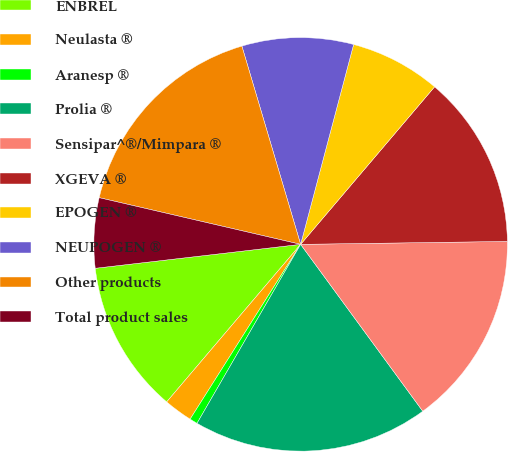Convert chart to OTSL. <chart><loc_0><loc_0><loc_500><loc_500><pie_chart><fcel>ENBREL<fcel>Neulasta ®<fcel>Aranesp ®<fcel>Prolia ®<fcel>Sensipar^®/Mimpara ®<fcel>XGEVA ®<fcel>EPOGEN ®<fcel>NEUPOGEN ®<fcel>Other products<fcel>Total product sales<nl><fcel>11.94%<fcel>2.24%<fcel>0.62%<fcel>18.41%<fcel>15.17%<fcel>13.56%<fcel>7.09%<fcel>8.71%<fcel>16.79%<fcel>5.47%<nl></chart> 